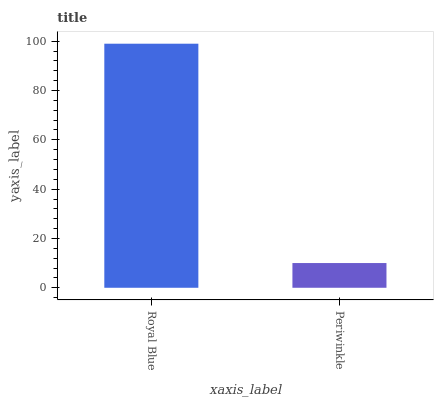Is Periwinkle the maximum?
Answer yes or no. No. Is Royal Blue greater than Periwinkle?
Answer yes or no. Yes. Is Periwinkle less than Royal Blue?
Answer yes or no. Yes. Is Periwinkle greater than Royal Blue?
Answer yes or no. No. Is Royal Blue less than Periwinkle?
Answer yes or no. No. Is Royal Blue the high median?
Answer yes or no. Yes. Is Periwinkle the low median?
Answer yes or no. Yes. Is Periwinkle the high median?
Answer yes or no. No. Is Royal Blue the low median?
Answer yes or no. No. 